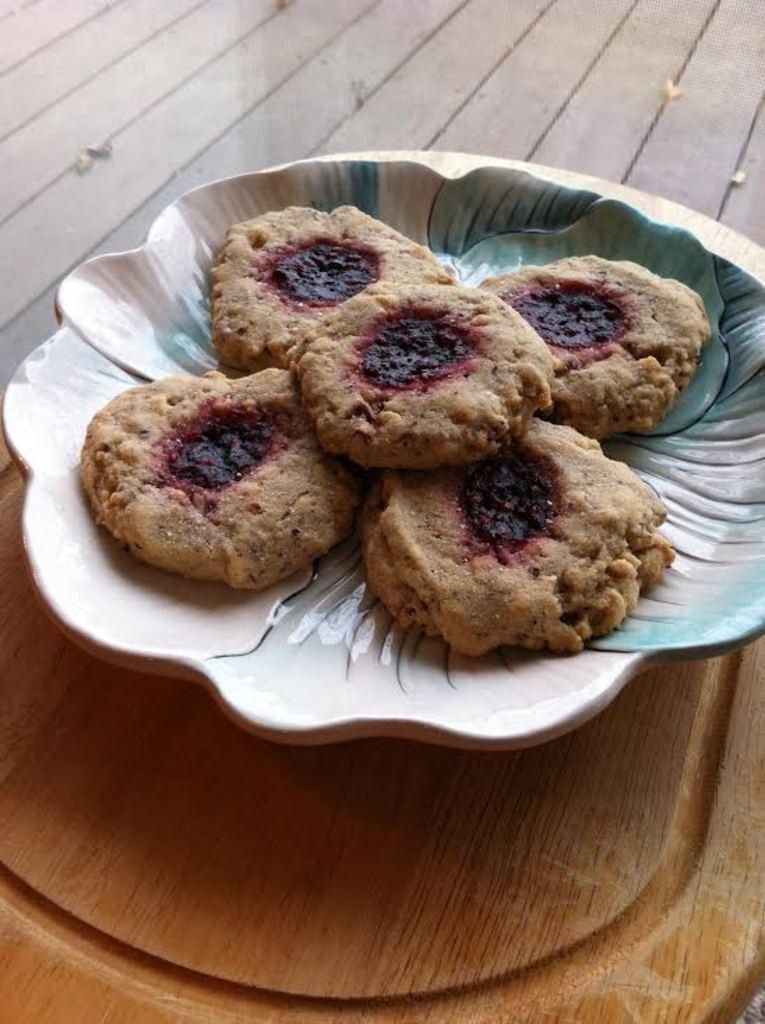Describe this image in one or two sentences. In this image there is a table. On the table there is a plate. In the plate there are five cookies which are kept one beside the other. 